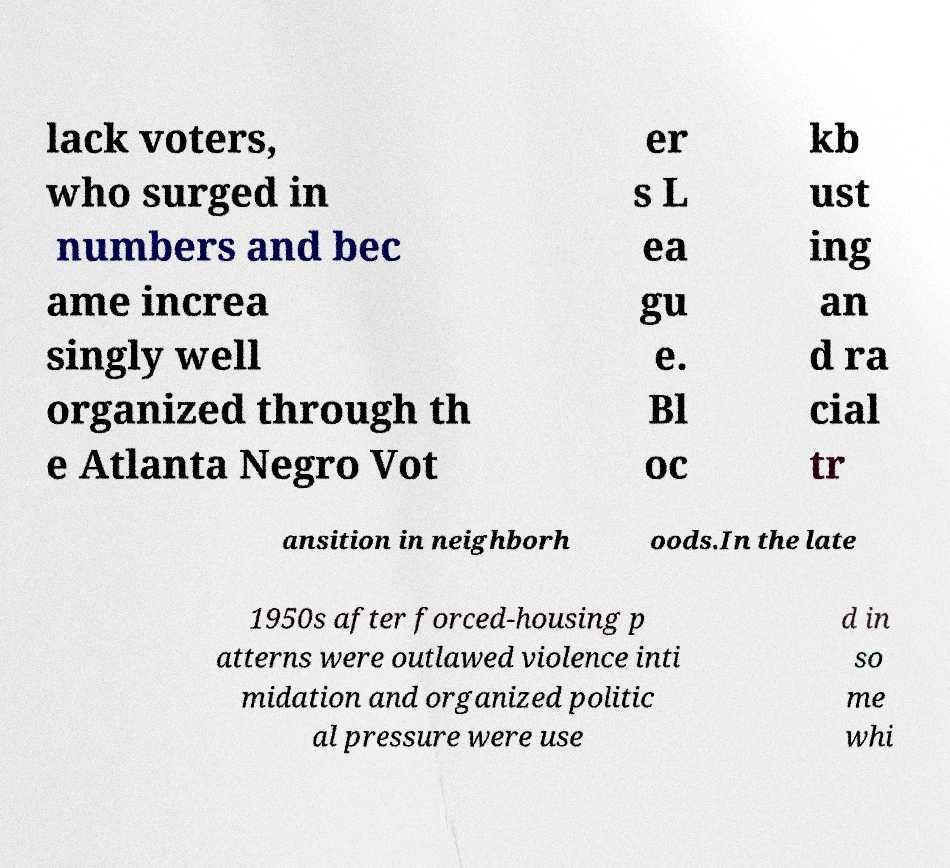Can you read and provide the text displayed in the image?This photo seems to have some interesting text. Can you extract and type it out for me? lack voters, who surged in numbers and bec ame increa singly well organized through th e Atlanta Negro Vot er s L ea gu e. Bl oc kb ust ing an d ra cial tr ansition in neighborh oods.In the late 1950s after forced-housing p atterns were outlawed violence inti midation and organized politic al pressure were use d in so me whi 